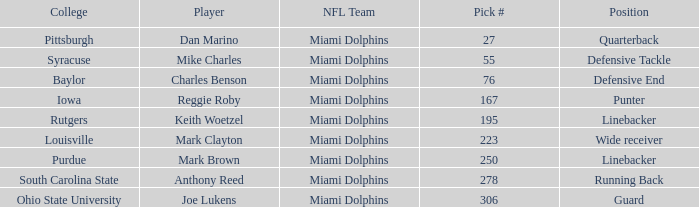Which Player has a Pick # lower than 223 and a Defensive End Position? Charles Benson. 